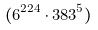Convert formula to latex. <formula><loc_0><loc_0><loc_500><loc_500>( 6 ^ { 2 2 4 } \cdot 3 8 3 ^ { 5 } )</formula> 